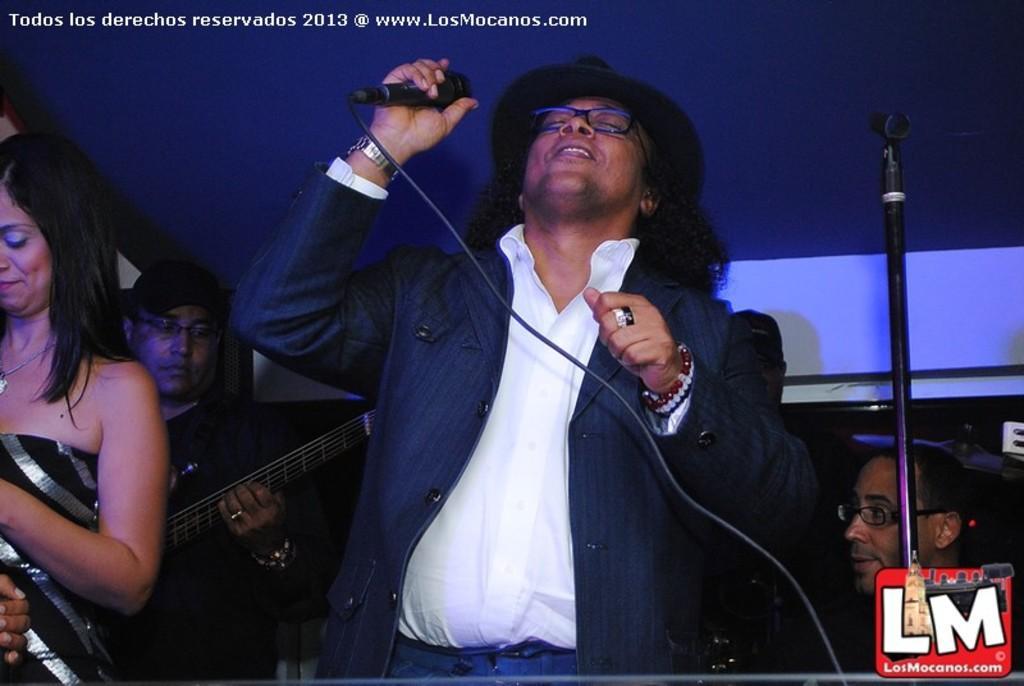Could you give a brief overview of what you see in this image? In this picture we can see a man who is holding a mike with his hand. He has spectacles. Here we can see some persons. 